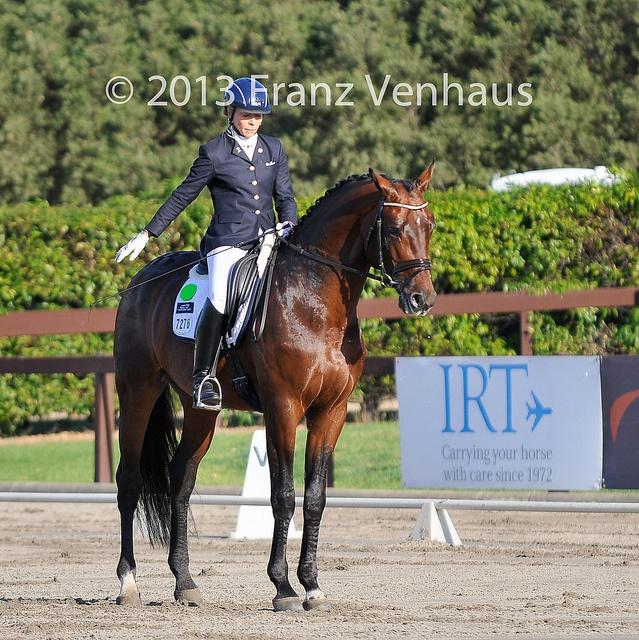Describe the objects in this image and their specific colors. I can see horse in olive, black, maroon, gray, and brown tones and people in olive, gray, black, and white tones in this image. 